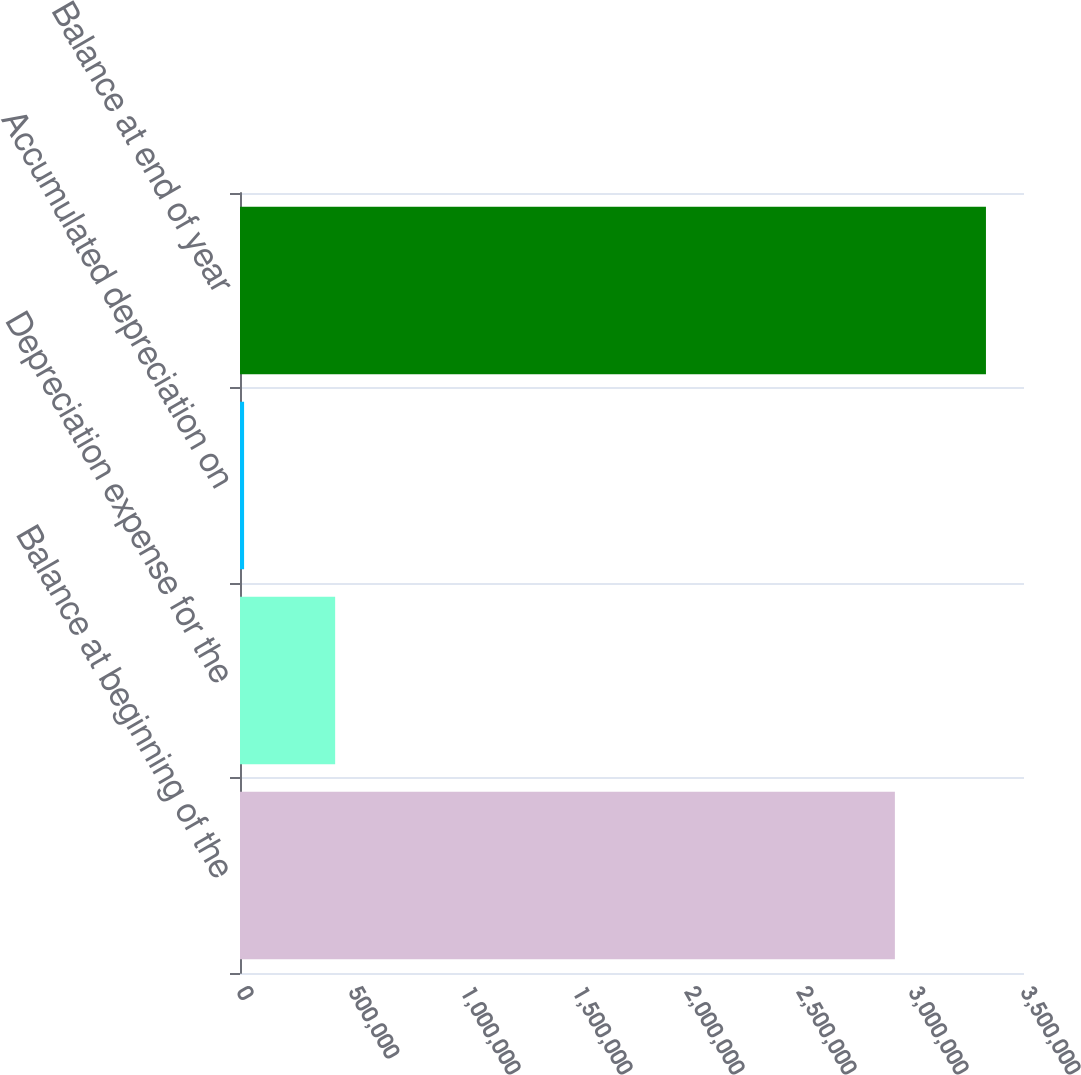<chart> <loc_0><loc_0><loc_500><loc_500><bar_chart><fcel>Balance at beginning of the<fcel>Depreciation expense for the<fcel>Accumulated depreciation on<fcel>Balance at end of year<nl><fcel>2.92362e+06<fcel>424772<fcel>18231<fcel>3.33017e+06<nl></chart> 